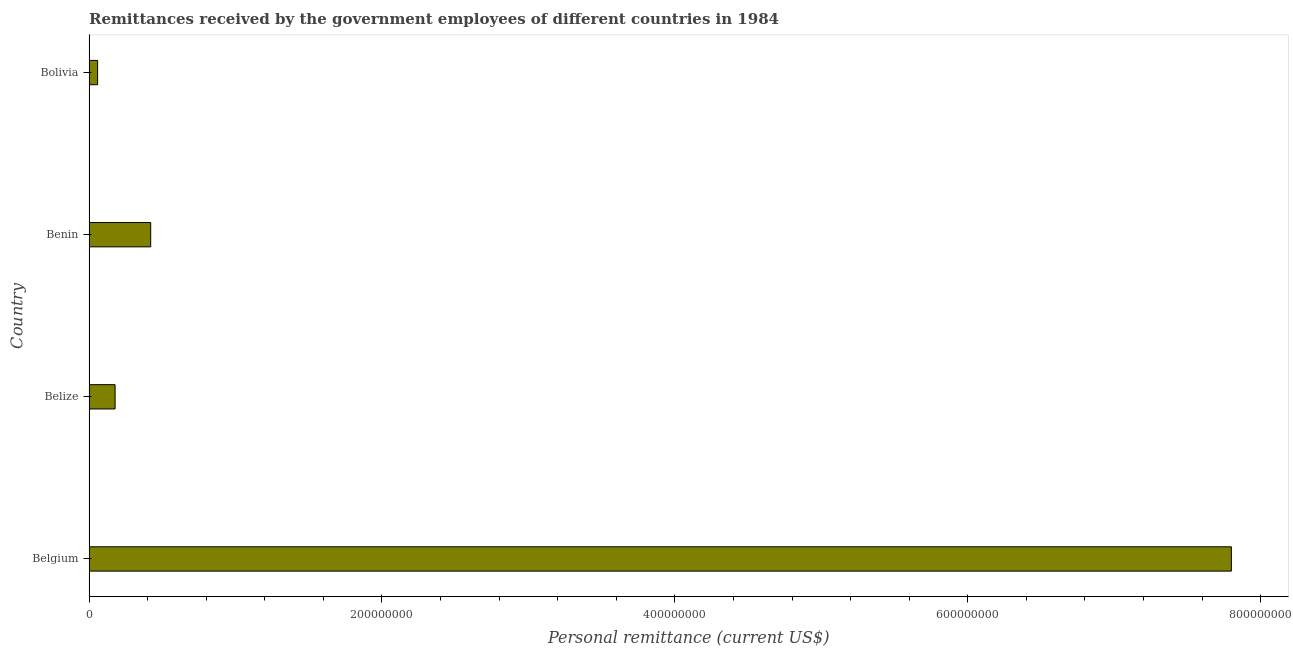Does the graph contain any zero values?
Give a very brief answer. No. What is the title of the graph?
Ensure brevity in your answer.  Remittances received by the government employees of different countries in 1984. What is the label or title of the X-axis?
Your response must be concise. Personal remittance (current US$). What is the personal remittances in Bolivia?
Keep it short and to the point. 5.80e+06. Across all countries, what is the maximum personal remittances?
Give a very brief answer. 7.80e+08. Across all countries, what is the minimum personal remittances?
Provide a succinct answer. 5.80e+06. In which country was the personal remittances maximum?
Your answer should be very brief. Belgium. In which country was the personal remittances minimum?
Give a very brief answer. Bolivia. What is the sum of the personal remittances?
Provide a succinct answer. 8.46e+08. What is the difference between the personal remittances in Belgium and Benin?
Your answer should be very brief. 7.38e+08. What is the average personal remittances per country?
Make the answer very short. 2.11e+08. What is the median personal remittances?
Offer a very short reply. 2.99e+07. In how many countries, is the personal remittances greater than 520000000 US$?
Offer a terse response. 1. What is the ratio of the personal remittances in Belgium to that in Bolivia?
Give a very brief answer. 134.49. Is the personal remittances in Benin less than that in Bolivia?
Make the answer very short. No. Is the difference between the personal remittances in Benin and Bolivia greater than the difference between any two countries?
Keep it short and to the point. No. What is the difference between the highest and the second highest personal remittances?
Make the answer very short. 7.38e+08. Is the sum of the personal remittances in Belize and Benin greater than the maximum personal remittances across all countries?
Offer a very short reply. No. What is the difference between the highest and the lowest personal remittances?
Offer a very short reply. 7.74e+08. In how many countries, is the personal remittances greater than the average personal remittances taken over all countries?
Give a very brief answer. 1. What is the difference between two consecutive major ticks on the X-axis?
Offer a terse response. 2.00e+08. Are the values on the major ticks of X-axis written in scientific E-notation?
Keep it short and to the point. No. What is the Personal remittance (current US$) of Belgium?
Your response must be concise. 7.80e+08. What is the Personal remittance (current US$) in Belize?
Offer a very short reply. 1.78e+07. What is the Personal remittance (current US$) in Benin?
Ensure brevity in your answer.  4.21e+07. What is the Personal remittance (current US$) of Bolivia?
Provide a short and direct response. 5.80e+06. What is the difference between the Personal remittance (current US$) in Belgium and Belize?
Make the answer very short. 7.62e+08. What is the difference between the Personal remittance (current US$) in Belgium and Benin?
Your answer should be compact. 7.38e+08. What is the difference between the Personal remittance (current US$) in Belgium and Bolivia?
Offer a terse response. 7.74e+08. What is the difference between the Personal remittance (current US$) in Belize and Benin?
Provide a short and direct response. -2.43e+07. What is the difference between the Personal remittance (current US$) in Belize and Bolivia?
Your answer should be very brief. 1.19e+07. What is the difference between the Personal remittance (current US$) in Benin and Bolivia?
Your answer should be compact. 3.63e+07. What is the ratio of the Personal remittance (current US$) in Belgium to that in Belize?
Keep it short and to the point. 43.95. What is the ratio of the Personal remittance (current US$) in Belgium to that in Benin?
Make the answer very short. 18.54. What is the ratio of the Personal remittance (current US$) in Belgium to that in Bolivia?
Offer a terse response. 134.49. What is the ratio of the Personal remittance (current US$) in Belize to that in Benin?
Keep it short and to the point. 0.42. What is the ratio of the Personal remittance (current US$) in Belize to that in Bolivia?
Offer a very short reply. 3.06. What is the ratio of the Personal remittance (current US$) in Benin to that in Bolivia?
Your answer should be compact. 7.25. 